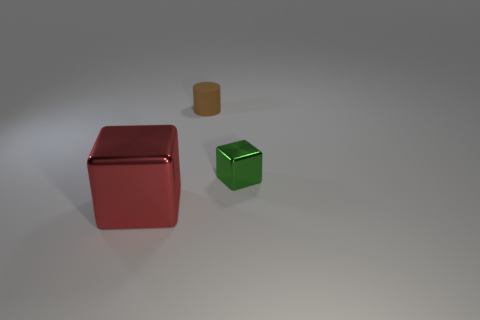What number of other objects are there of the same size as the brown cylinder?
Your answer should be compact. 1. Is the number of small green shiny objects that are right of the big red metallic cube the same as the number of tiny green metal blocks on the left side of the brown object?
Give a very brief answer. No. There is another big shiny thing that is the same shape as the green metallic object; what color is it?
Provide a succinct answer. Red. Is there anything else that has the same shape as the red object?
Provide a succinct answer. Yes. Does the object that is behind the tiny green object have the same color as the small metallic object?
Keep it short and to the point. No. There is a green metallic object that is the same shape as the red thing; what size is it?
Ensure brevity in your answer.  Small. What number of large objects have the same material as the small green block?
Give a very brief answer. 1. Is there a small brown rubber object that is behind the matte cylinder on the left side of the block right of the large red thing?
Keep it short and to the point. No. What shape is the red shiny object?
Provide a succinct answer. Cube. Do the small thing behind the small green object and the cube behind the red thing have the same material?
Offer a terse response. No. 